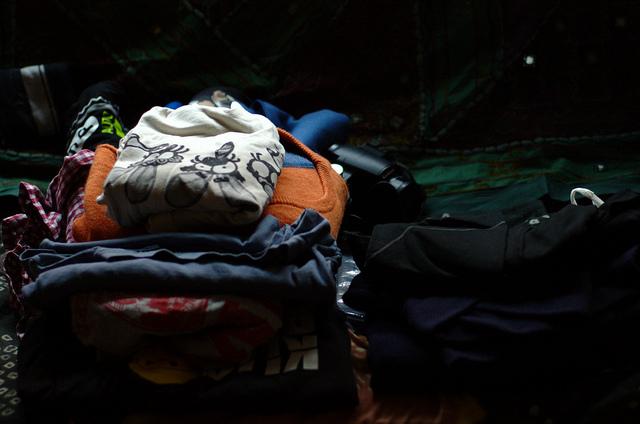What is folded here?
Give a very brief answer. Clothes. What is the orange object?
Write a very short answer. Shirt. Are the shirts stacked?
Be succinct. Yes. 